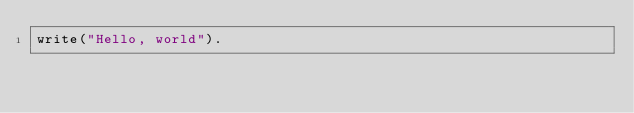<code> <loc_0><loc_0><loc_500><loc_500><_Prolog_>write("Hello, world").</code> 